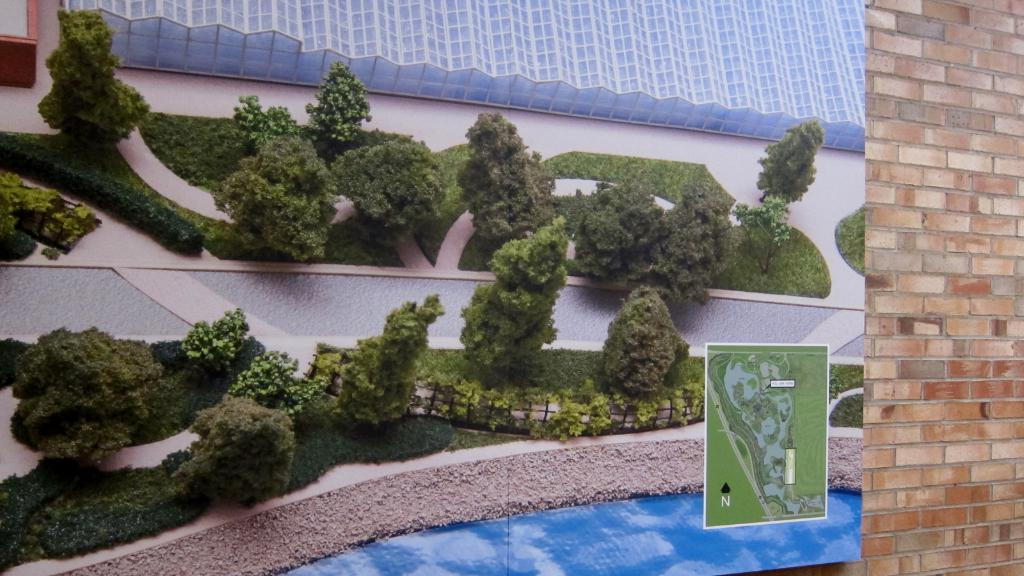What is on the wall in the image? There is a board on the wall in the image. What is depicted on the board? The board contains pictures of trees, plants, grass, and a walkway. What is on the right side of the image? There is a wall on the right side of the image. Where is the coat hanging in the image? There is no coat present in the image. What type of seat can be seen in the image? There is no seat present in the image. 